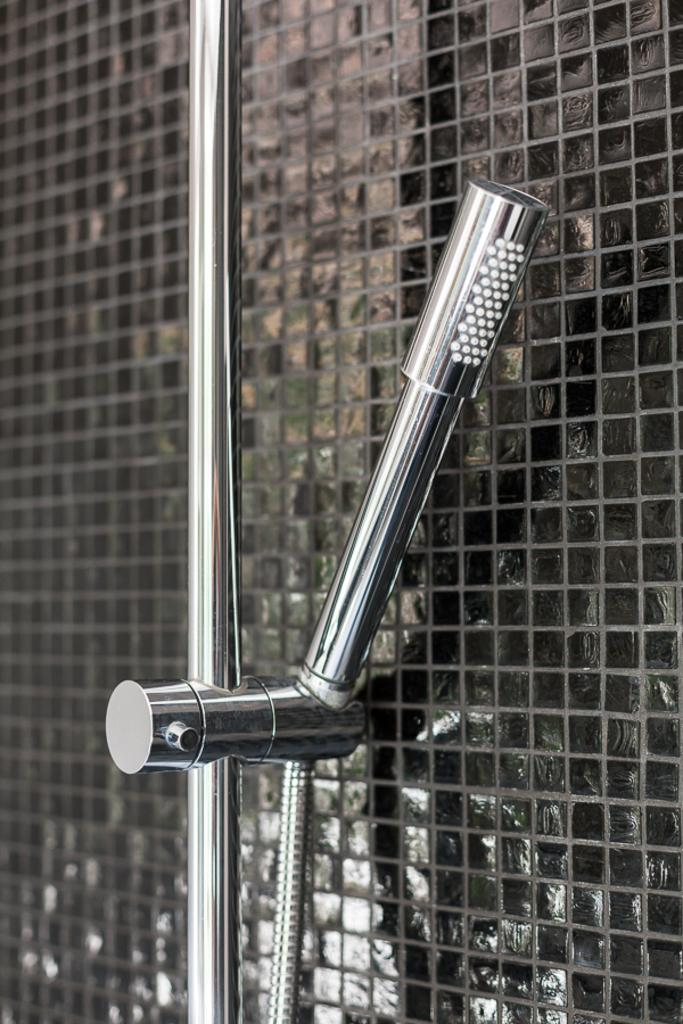What is located in the foreground of the image? There is a shower in the foreground of the image. How is the shower connected to the wall? The shower is attached to a wall. Where is the seat located in the image? There is no seat present in the image. What type of cord is connected to the shower in the image? There is no cord connected to the shower in the image. 